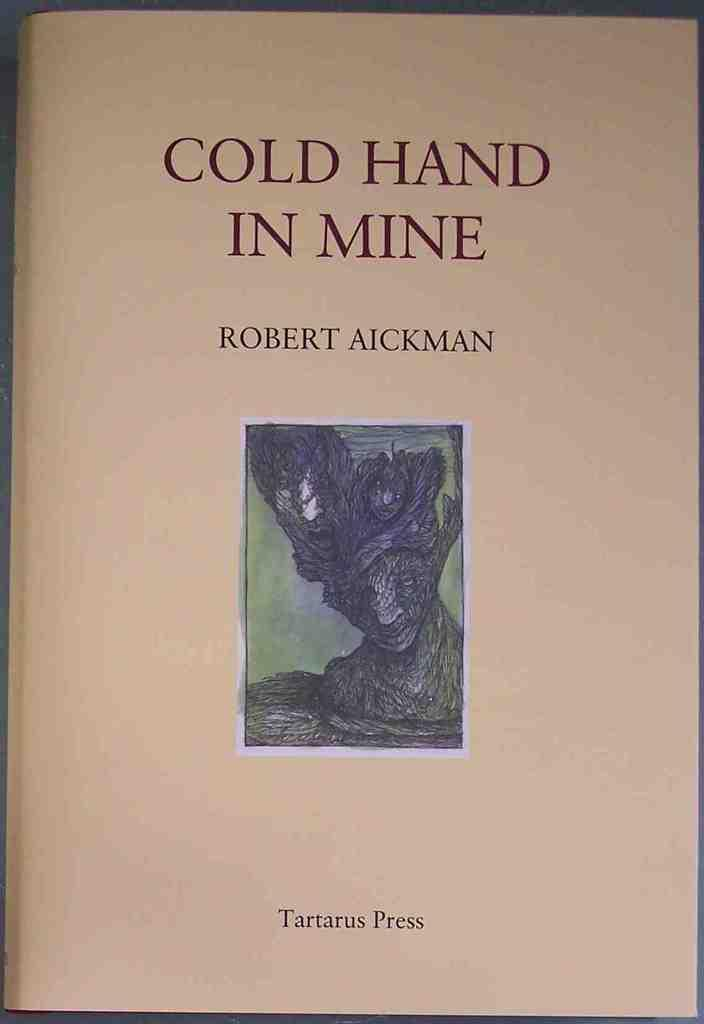What is the main object in the foreground of the image? There is an object in the foreground that resembles paper. What can be observed on the paper-like object? The paper-like object has text on it. Is there any visual element in the center of the paper-like object? Yes, there is an image in the middle of the paper-like object. What type of acoustics can be heard from the sponge in the image? There is no sponge present in the image, and therefore no acoustics can be heard from it. What musical instrument is being played by the person in the image? There is no person or musical instrument present in the image. 